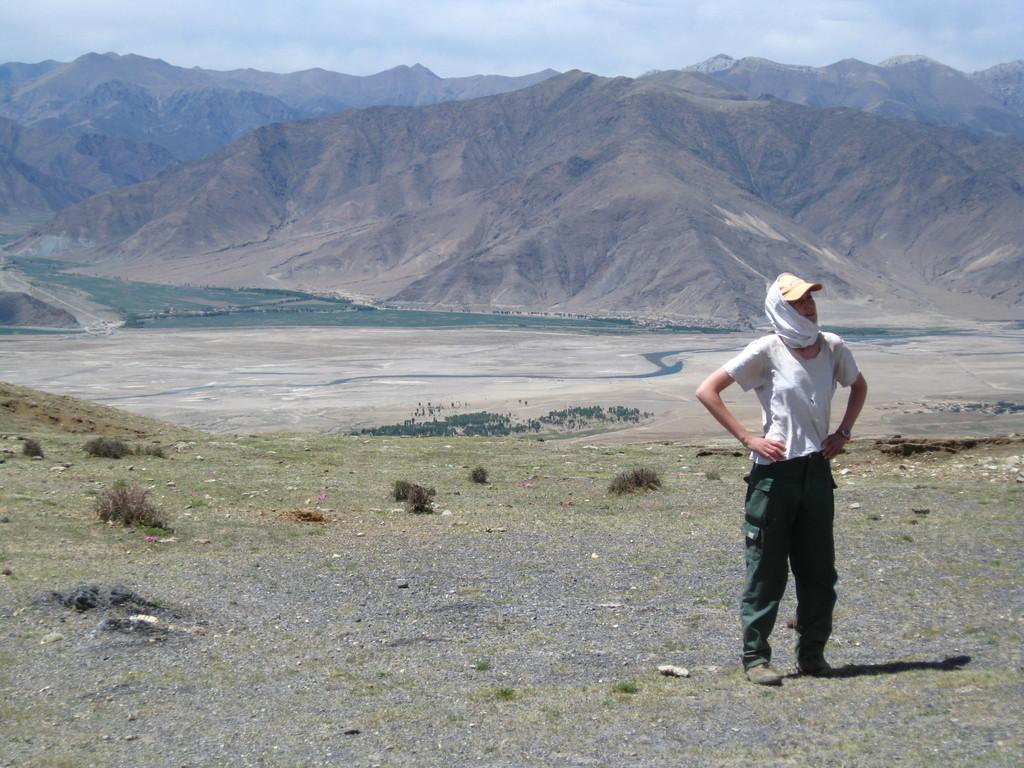What is the main subject in the foreground of the image? There is a person standing in the foreground of the image. What is the person standing on? The person is standing on the ground. What can be seen in the background of the image? There are mountains and the sky visible in the background of the image. Can you determine the time of day the image was taken? The image was likely taken during the day, as the sky is visible and there is sufficient light. How many cattle are grazing in the foreground of the image? There are no cattle present in the image; the main subject is a person standing in the foreground. What type of smile does the person have in the image? The image does not show the person's facial expression, so it is impossible to determine if they are smiling or not. 